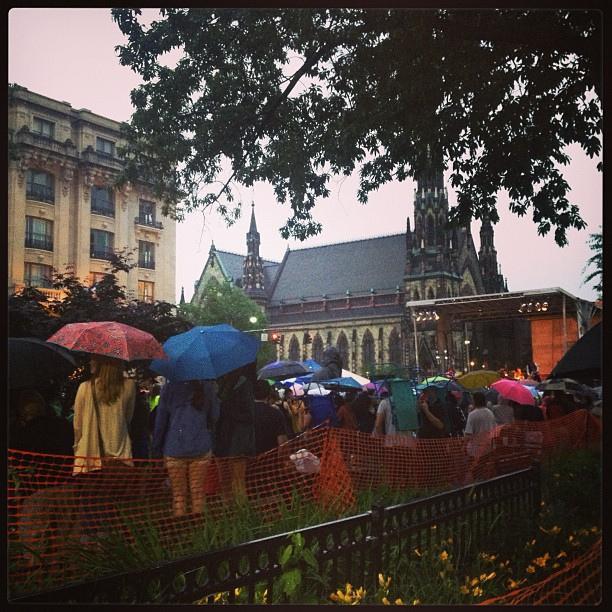How many people can you see?
Give a very brief answer. 4. How many umbrellas are visible?
Give a very brief answer. 4. 